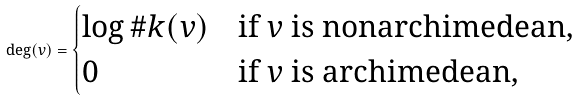Convert formula to latex. <formula><loc_0><loc_0><loc_500><loc_500>\deg ( v ) = \begin{cases} \log \# k ( v ) & \text {if $v$ is nonarchimedean,} \\ 0 & \text {if $v$ is archimedean,} \end{cases}</formula> 